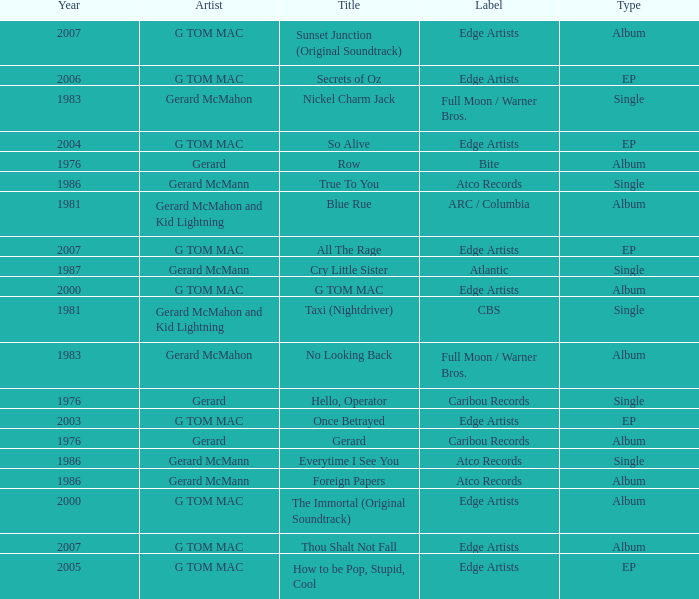Which Title has a Type of album and a Year larger than 1986? G TOM MAC, The Immortal (Original Soundtrack), Sunset Junction (Original Soundtrack), Thou Shalt Not Fall. 